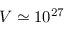<formula> <loc_0><loc_0><loc_500><loc_500>V \simeq 1 0 ^ { 2 7 }</formula> 